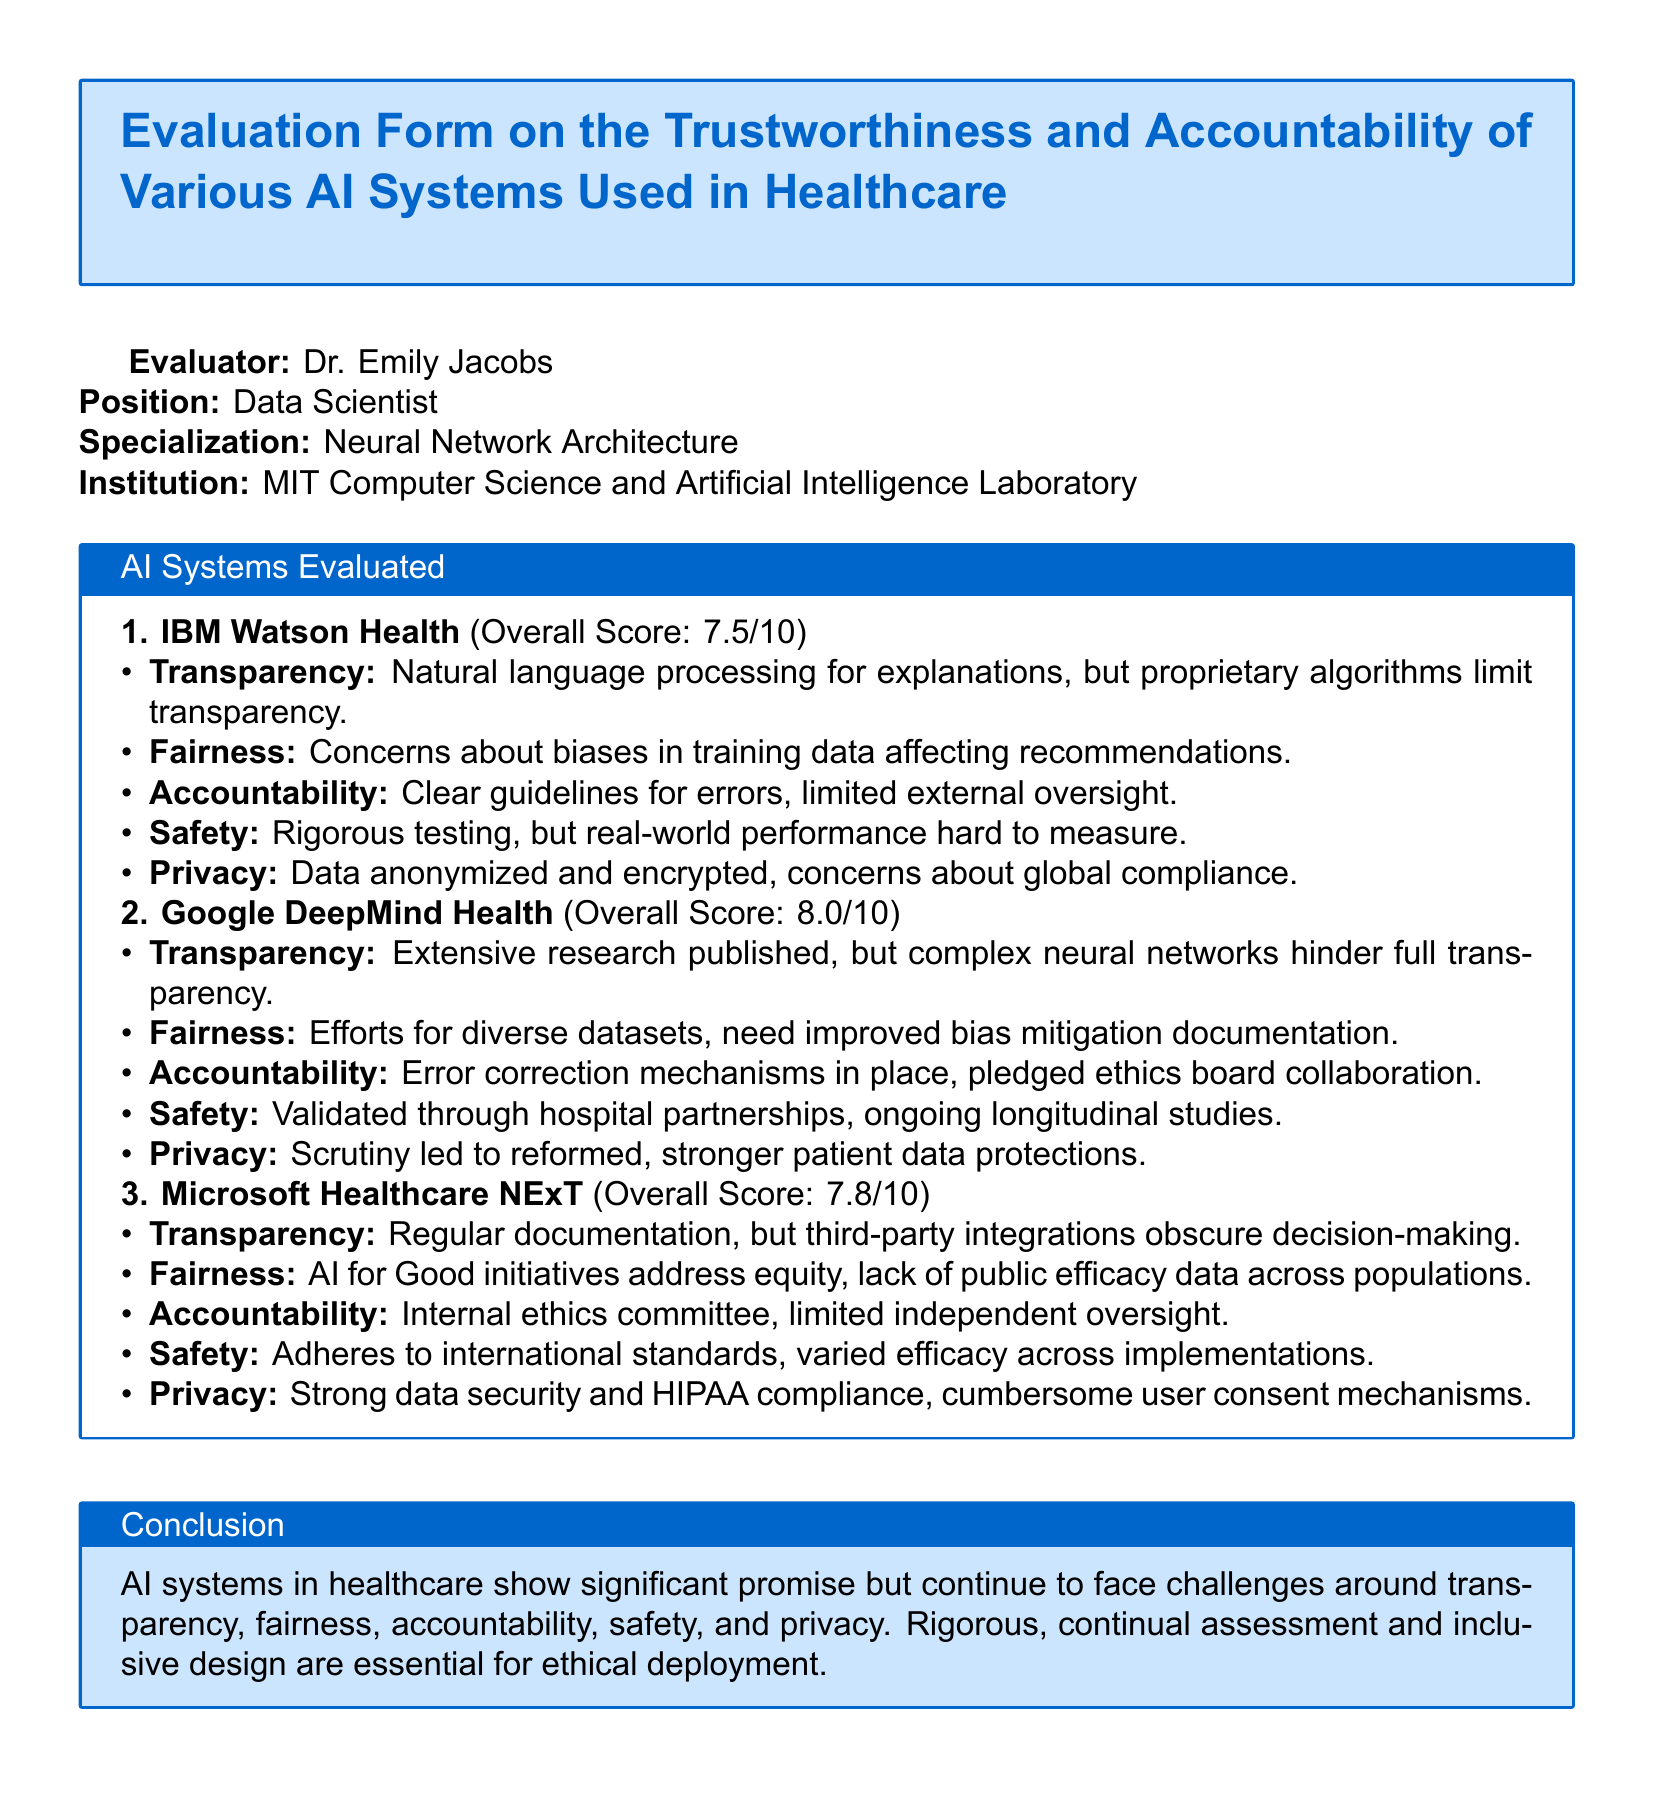What is the overall score for IBM Watson Health? The overall score is stated directly in the document under AI Systems Evaluated.
Answer: 7.5/10 What institution is Dr. Emily Jacobs affiliated with? The document mentions Dr. Emily Jacobs's position and institution at the beginning.
Answer: MIT Computer Science and Artificial Intelligence Laboratory What accountability measures are in place for Google DeepMind Health? The accountability measures are described in the evaluation details for Google DeepMind Health in the document.
Answer: Error correction mechanisms What aspect of transparency is highlighted for Microsoft Healthcare NExT? The document discusses transparency for each AI system, specifically for Microsoft Healthcare NExT.
Answer: Regular documentation How does Google DeepMind Health address privacy concerns? Privacy concerns are outlined in the evaluation of Google DeepMind Health in the document.
Answer: Stronger patient data protections What is noted as a need in the fairness section for Google DeepMind Health? The document highlights specific needs in the fairness section in the evaluation.
Answer: Improved bias mitigation documentation 